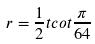Convert formula to latex. <formula><loc_0><loc_0><loc_500><loc_500>r = \frac { 1 } { 2 } t c o t \frac { \pi } { 6 4 }</formula> 